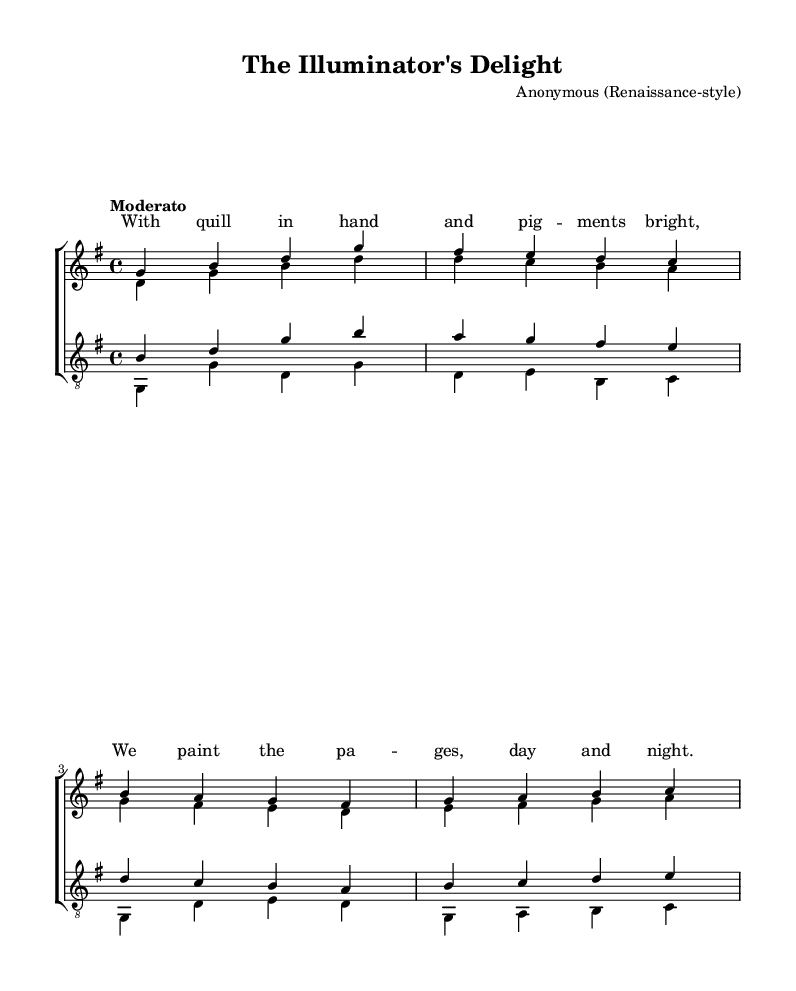What is the key signature of this music? The key signature is G major, which has one sharp (F#).
Answer: G major What is the time signature of the piece? The time signature indicated is 4/4, meaning there are four beats in a measure.
Answer: 4/4 What is the tempo marking for this piece? The tempo marking is "Moderato," suggesting a moderate pace for the performance.
Answer: Moderato How many parts are in the choir? The choir consists of four parts: soprano, alto, tenor, and bass.
Answer: Four Which voice sings the lowest notes? The bass voice is designated to sing the lowest notes, indicated by the lowest staff in the score.
Answer: Bass What is the first lyric line of the song? The first lyric line is "With quill in hand and pig -- ments bright," as noted in the lyric section of the score.
Answer: With quill in hand and pig -- ments bright How does the tenor voice relate to the soprano voice in terms of pitch range? The tenor voice is positioned a whole octave lower than the soprano voice, since it is placed on a clef that indicates singing pitch lower than the soprano.
Answer: A whole octave lower 